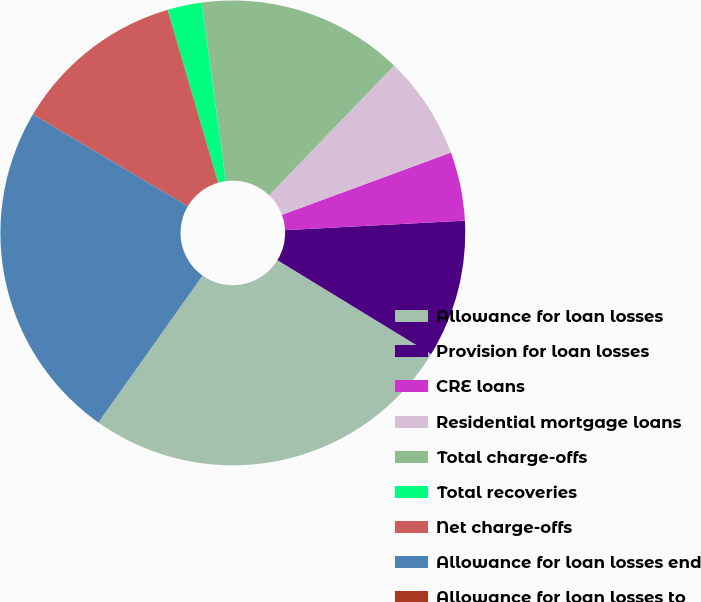Convert chart to OTSL. <chart><loc_0><loc_0><loc_500><loc_500><pie_chart><fcel>Allowance for loan losses<fcel>Provision for loan losses<fcel>CRE loans<fcel>Residential mortgage loans<fcel>Total charge-offs<fcel>Total recoveries<fcel>Net charge-offs<fcel>Allowance for loan losses end<fcel>Allowance for loan losses to<nl><fcel>26.09%<fcel>9.57%<fcel>4.78%<fcel>7.17%<fcel>14.35%<fcel>2.39%<fcel>11.96%<fcel>23.7%<fcel>0.0%<nl></chart> 